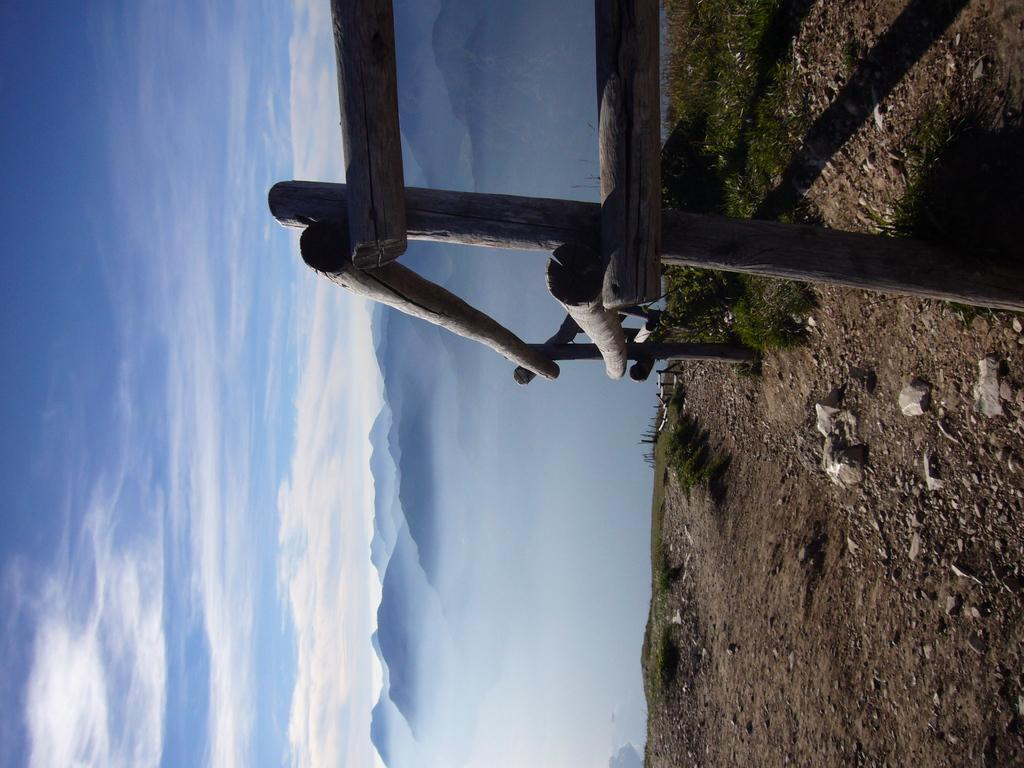What type of barrier is visible in the image? There is a wooden fence in the image. What type of natural elements can be seen on the ground in the image? There are stones and grass in the image, as well as plants on the ground. What type of landscape feature is visible in the background of the image? There are mountains in the background of the image. What is visible in the sky in the background of the image? There are clouds in the sky in the background of the image. How many kittens are playing with a pen in the image? There are no kittens or pens present in the image. What is the relation between the mountains and the wooden fence in the image? The provided facts do not mention any relation between the mountains and the wooden fence; they are simply two separate elements in the image. 